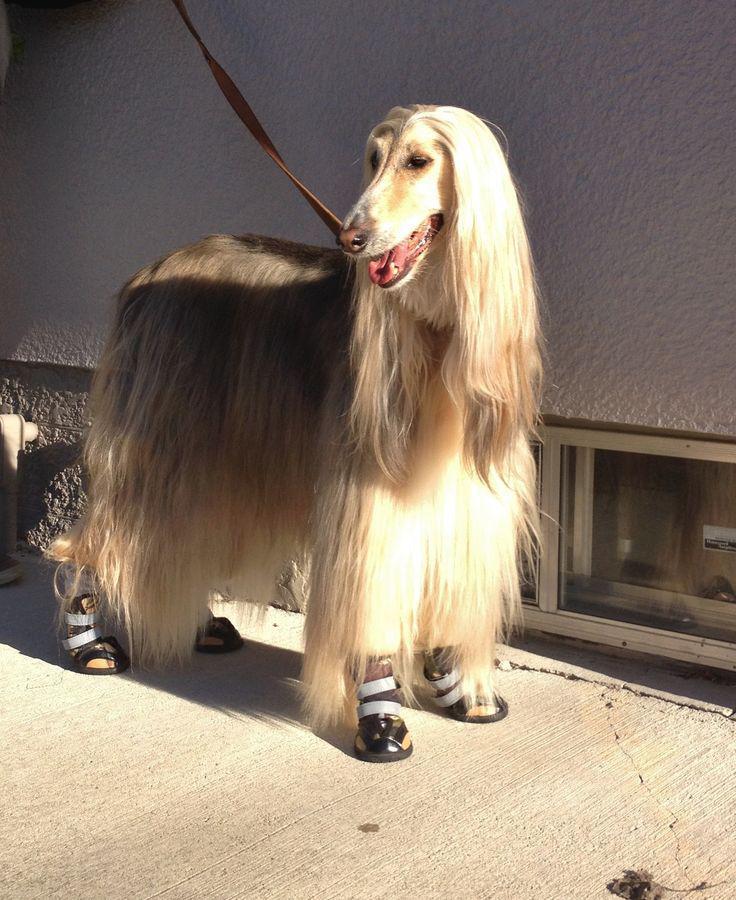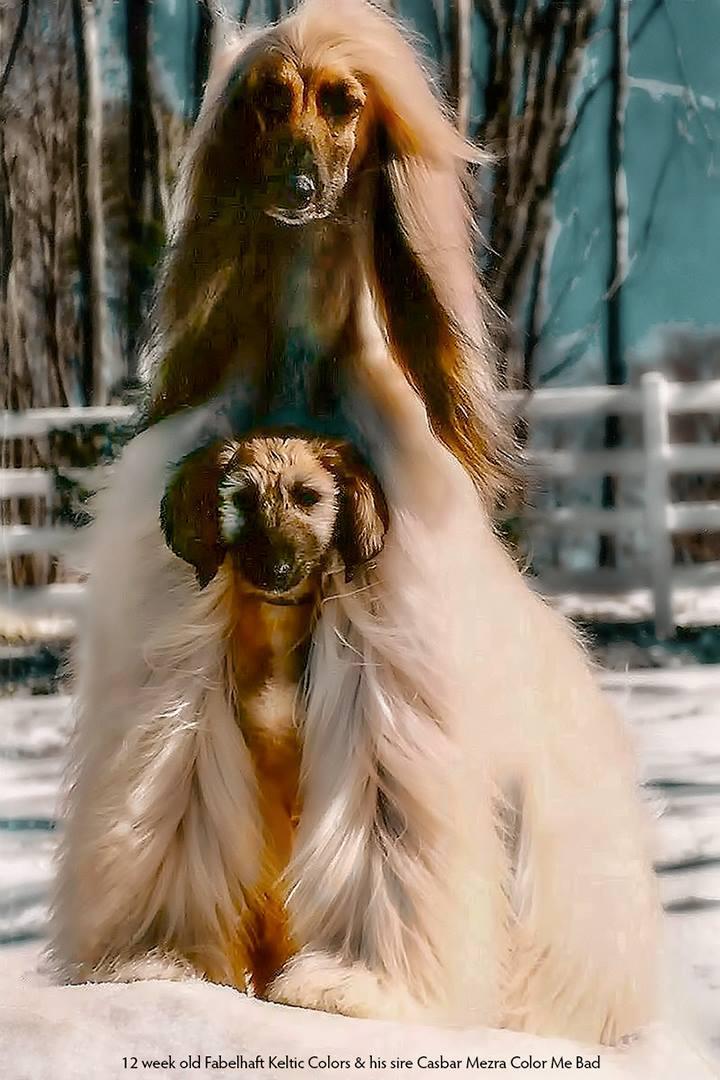The first image is the image on the left, the second image is the image on the right. Assess this claim about the two images: "There are". Correct or not? Answer yes or no. No. The first image is the image on the left, the second image is the image on the right. Evaluate the accuracy of this statement regarding the images: "A sitting dog in one image is wearing an ornate head covering that extends down its neck.". Is it true? Answer yes or no. No. 